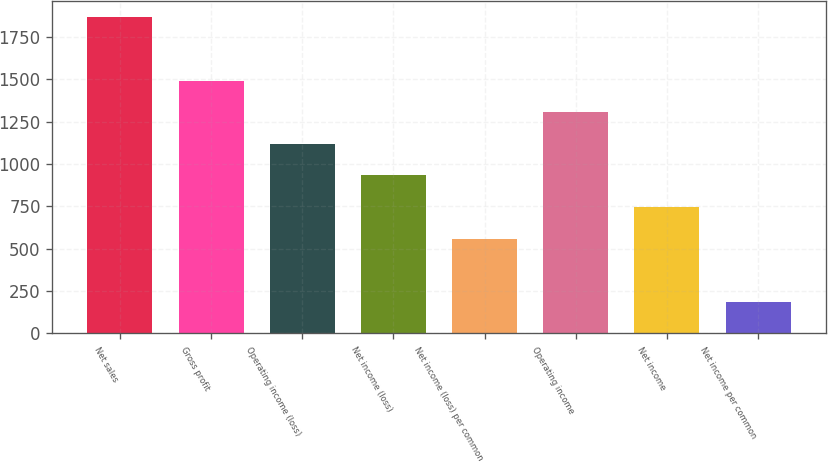Convert chart to OTSL. <chart><loc_0><loc_0><loc_500><loc_500><bar_chart><fcel>Net sales<fcel>Gross profit<fcel>Operating income (loss)<fcel>Net income (loss)<fcel>Net income (loss) per common<fcel>Operating income<fcel>Net income<fcel>Net income per common<nl><fcel>1866<fcel>1492.83<fcel>1119.63<fcel>933.03<fcel>559.83<fcel>1306.23<fcel>746.43<fcel>186.63<nl></chart> 